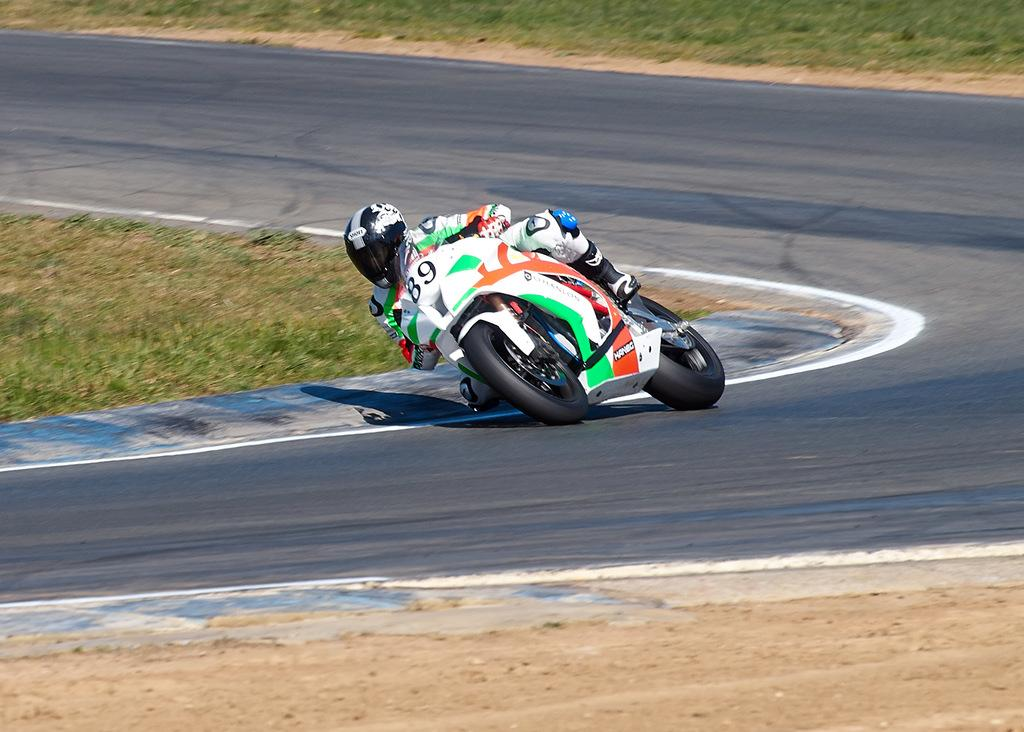What is the person in the image doing? The person is riding a motorcycle. What protective gear is the person wearing? The person is wearing gloves, knee pads, and a helmet. Where is the motorcycle located? The motorcycle is on a road. What type of ground surface is visible in the image? There is grass on the ground. What type of gun can be seen in the person's hand in the image? There is no gun present in the image; the person is wearing gloves and riding a motorcycle. What type of destruction can be seen in the image? There is no destruction present in the image; it features a person riding a motorcycle on a road with grass on the ground. 